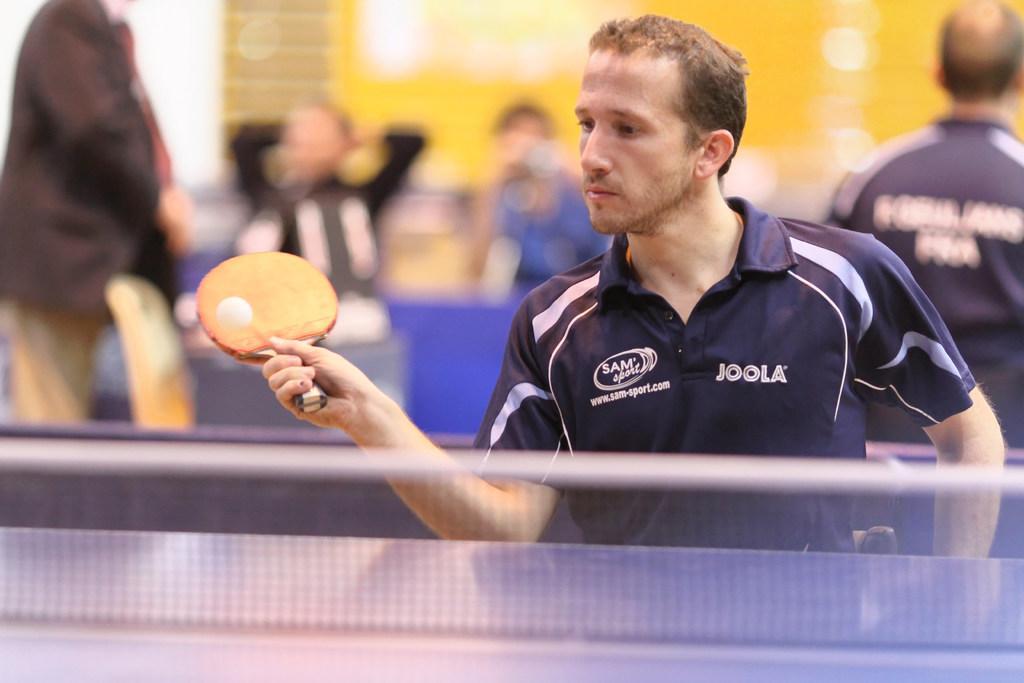Describe this image in one or two sentences. In this image a man wearing blue t-shirt is playing table tennis. He is holding a bat. Behind him there are many other persons. 